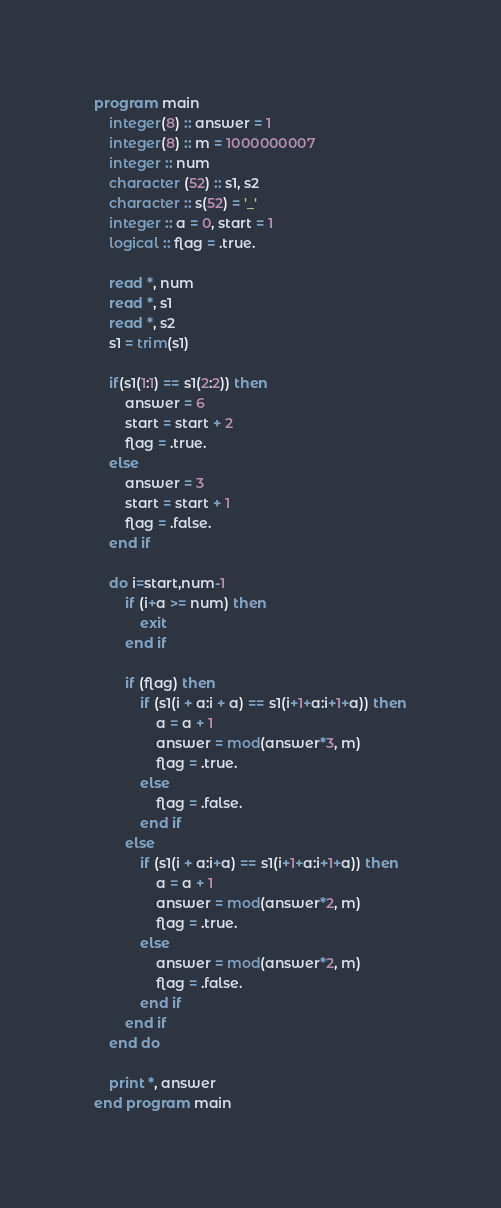Convert code to text. <code><loc_0><loc_0><loc_500><loc_500><_FORTRAN_>program main
    integer(8) :: answer = 1
    integer(8) :: m = 1000000007
    integer :: num
    character (52) :: s1, s2
    character :: s(52) = '_'
    integer :: a = 0, start = 1
    logical :: flag = .true.

    read *, num
    read *, s1
    read *, s2
    s1 = trim(s1)

    if(s1(1:1) == s1(2:2)) then
        answer = 6
        start = start + 2
        flag = .true.
    else
        answer = 3
        start = start + 1
        flag = .false.
    end if

    do i=start,num-1
        if (i+a >= num) then
            exit
        end if

        if (flag) then
            if (s1(i + a:i + a) == s1(i+1+a:i+1+a)) then
                a = a + 1
                answer = mod(answer*3, m)
                flag = .true.
            else
                flag = .false.
            end if
        else
            if (s1(i + a:i+a) == s1(i+1+a:i+1+a)) then
                a = a + 1
                answer = mod(answer*2, m)
                flag = .true.
            else
                answer = mod(answer*2, m)
                flag = .false.
            end if
        end if
    end do

    print *, answer
end program main</code> 